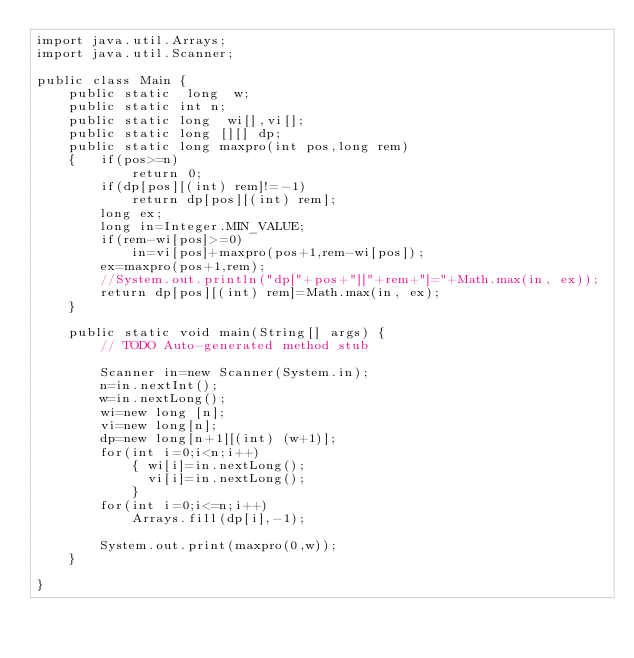<code> <loc_0><loc_0><loc_500><loc_500><_Java_>import java.util.Arrays;
import java.util.Scanner;

public class Main {
	public static  long  w;
	public static int n;
	public static long  wi[],vi[];
	public static long [][] dp;
	public static long maxpro(int pos,long rem)
	{   if(pos>=n)
			return 0;
		if(dp[pos][(int) rem]!=-1)
			return dp[pos][(int) rem];
		long ex;
		long in=Integer.MIN_VALUE;
		if(rem-wi[pos]>=0)
			in=vi[pos]+maxpro(pos+1,rem-wi[pos]);
		ex=maxpro(pos+1,rem);
		//System.out.println("dp["+pos+"]["+rem+"]="+Math.max(in, ex));
		return dp[pos][(int) rem]=Math.max(in, ex);
	}
	
	public static void main(String[] args) {
		// TODO Auto-generated method stub
		
		Scanner in=new Scanner(System.in);
		n=in.nextInt();
		w=in.nextLong();
		wi=new long [n];
		vi=new long[n];
		dp=new long[n+1][(int) (w+1)];
		for(int i=0;i<n;i++)
			{ wi[i]=in.nextLong();
			  vi[i]=in.nextLong();
			}
		for(int i=0;i<=n;i++)
			Arrays.fill(dp[i],-1);
	
		System.out.print(maxpro(0,w));
	}

}
</code> 